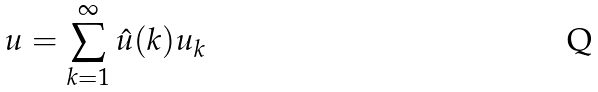Convert formula to latex. <formula><loc_0><loc_0><loc_500><loc_500>u = \sum _ { k = 1 } ^ { \infty } \hat { u } ( k ) u _ { k }</formula> 